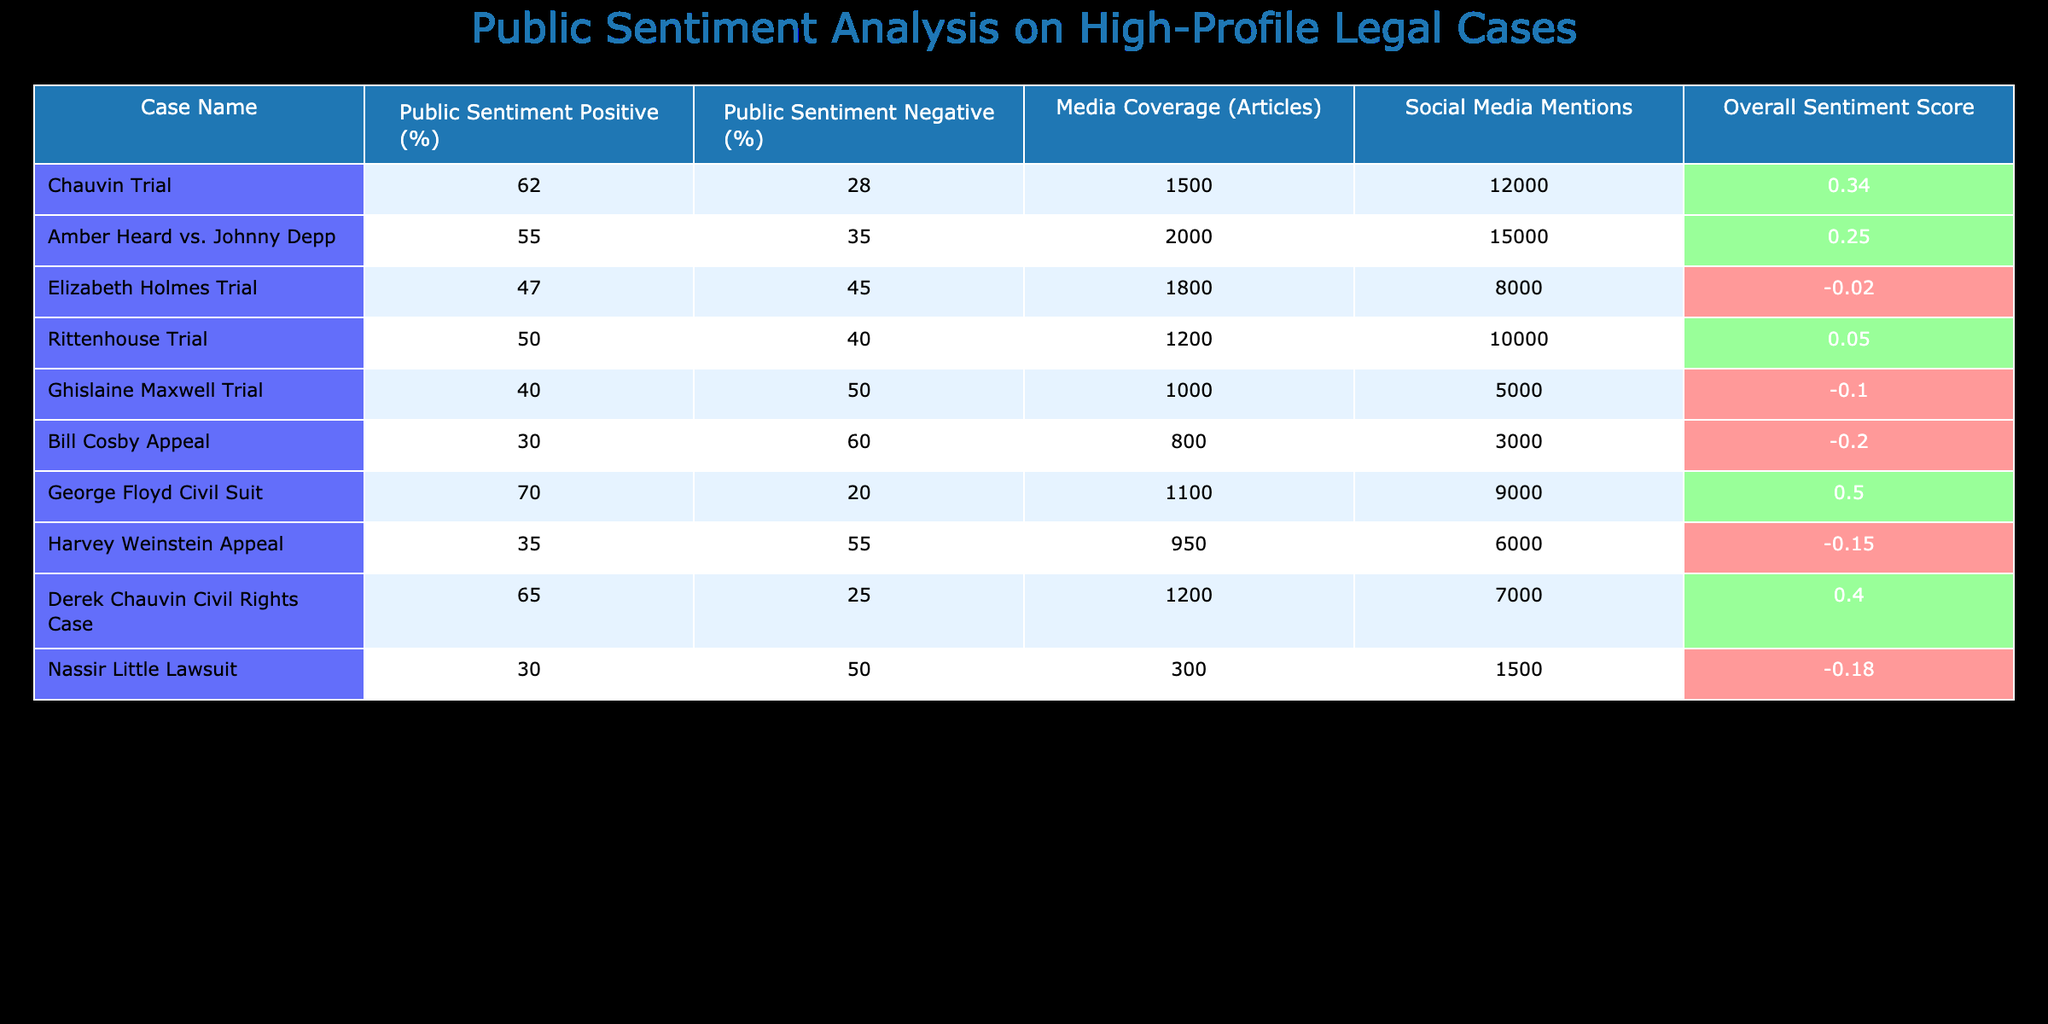What is the public sentiment percentage for the George Floyd Civil Suit? The table shows a public sentiment positive percentage for the George Floyd Civil Suit as 70%.
Answer: 70% Which case has the highest percentage of negative public sentiment? By reviewing the negative sentiment percentages, the Bill Cosby Appeal has the highest at 60%.
Answer: 60% What is the overall sentiment score for the Rittenhouse Trial? The overall sentiment score for the Rittenhouse Trial is listed as 0.05.
Answer: 0.05 How many articles covered the Amber Heard vs. Johnny Depp case compared to the Ghislaine Maxwell Trial? The Amber Heard vs. Johnny Depp case was covered in 2000 articles, whereas the Ghislaine Maxwell Trial was covered in 1000 articles. The difference is 2000 - 1000 = 1000 articles.
Answer: 1000 articles Which case had the lowest overall sentiment score and what was it? The case with the lowest overall sentiment score is the Bill Cosby Appeal, with a score of -0.20.
Answer: -0.20 Is the public sentiment for the Derek Chauvin Civil Rights Case more positive than that for the Harvey Weinstein Appeal? Yes, the Derek Chauvin Civil Rights Case has a positive sentiment of 65%, while the Harvey Weinstein Appeal has a positive sentiment of 35%.
Answer: Yes What is the average public sentiment positive percentage across all cases? To find the average, we add the positive percentages: (62 + 55 + 47 + 50 + 40 + 30 + 70 + 35 + 65 + 30) =  434. Dividing by the number of cases (10), the average is 434 / 10 = 43.4%.
Answer: 43.4% How many social media mentions does the Elizabeth Holmes Trial have compared to the George Floyd Civil Suit? The Elizabeth Holmes Trial has 8000 social media mentions, while the George Floyd Civil Suit has 9000 mentions. The George Floyd Civil Suit exceeded the Elizabeth Holmes Trial by 9000 - 8000 = 1000 mentions.
Answer: 1000 mentions Which case has a positive public sentiment percentage lower than 50%? The cases with a positive sentiment lower than 50% are the Elizabeth Holmes Trial (47%), Ghislaine Maxwell Trial (40%), Bill Cosby Appeal (30%), and Nassir Little Lawsuit (30%).
Answer: Elizabeth Holmes Trial, Ghislaine Maxwell Trial, Bill Cosby Appeal, Nassir Little Lawsuit 